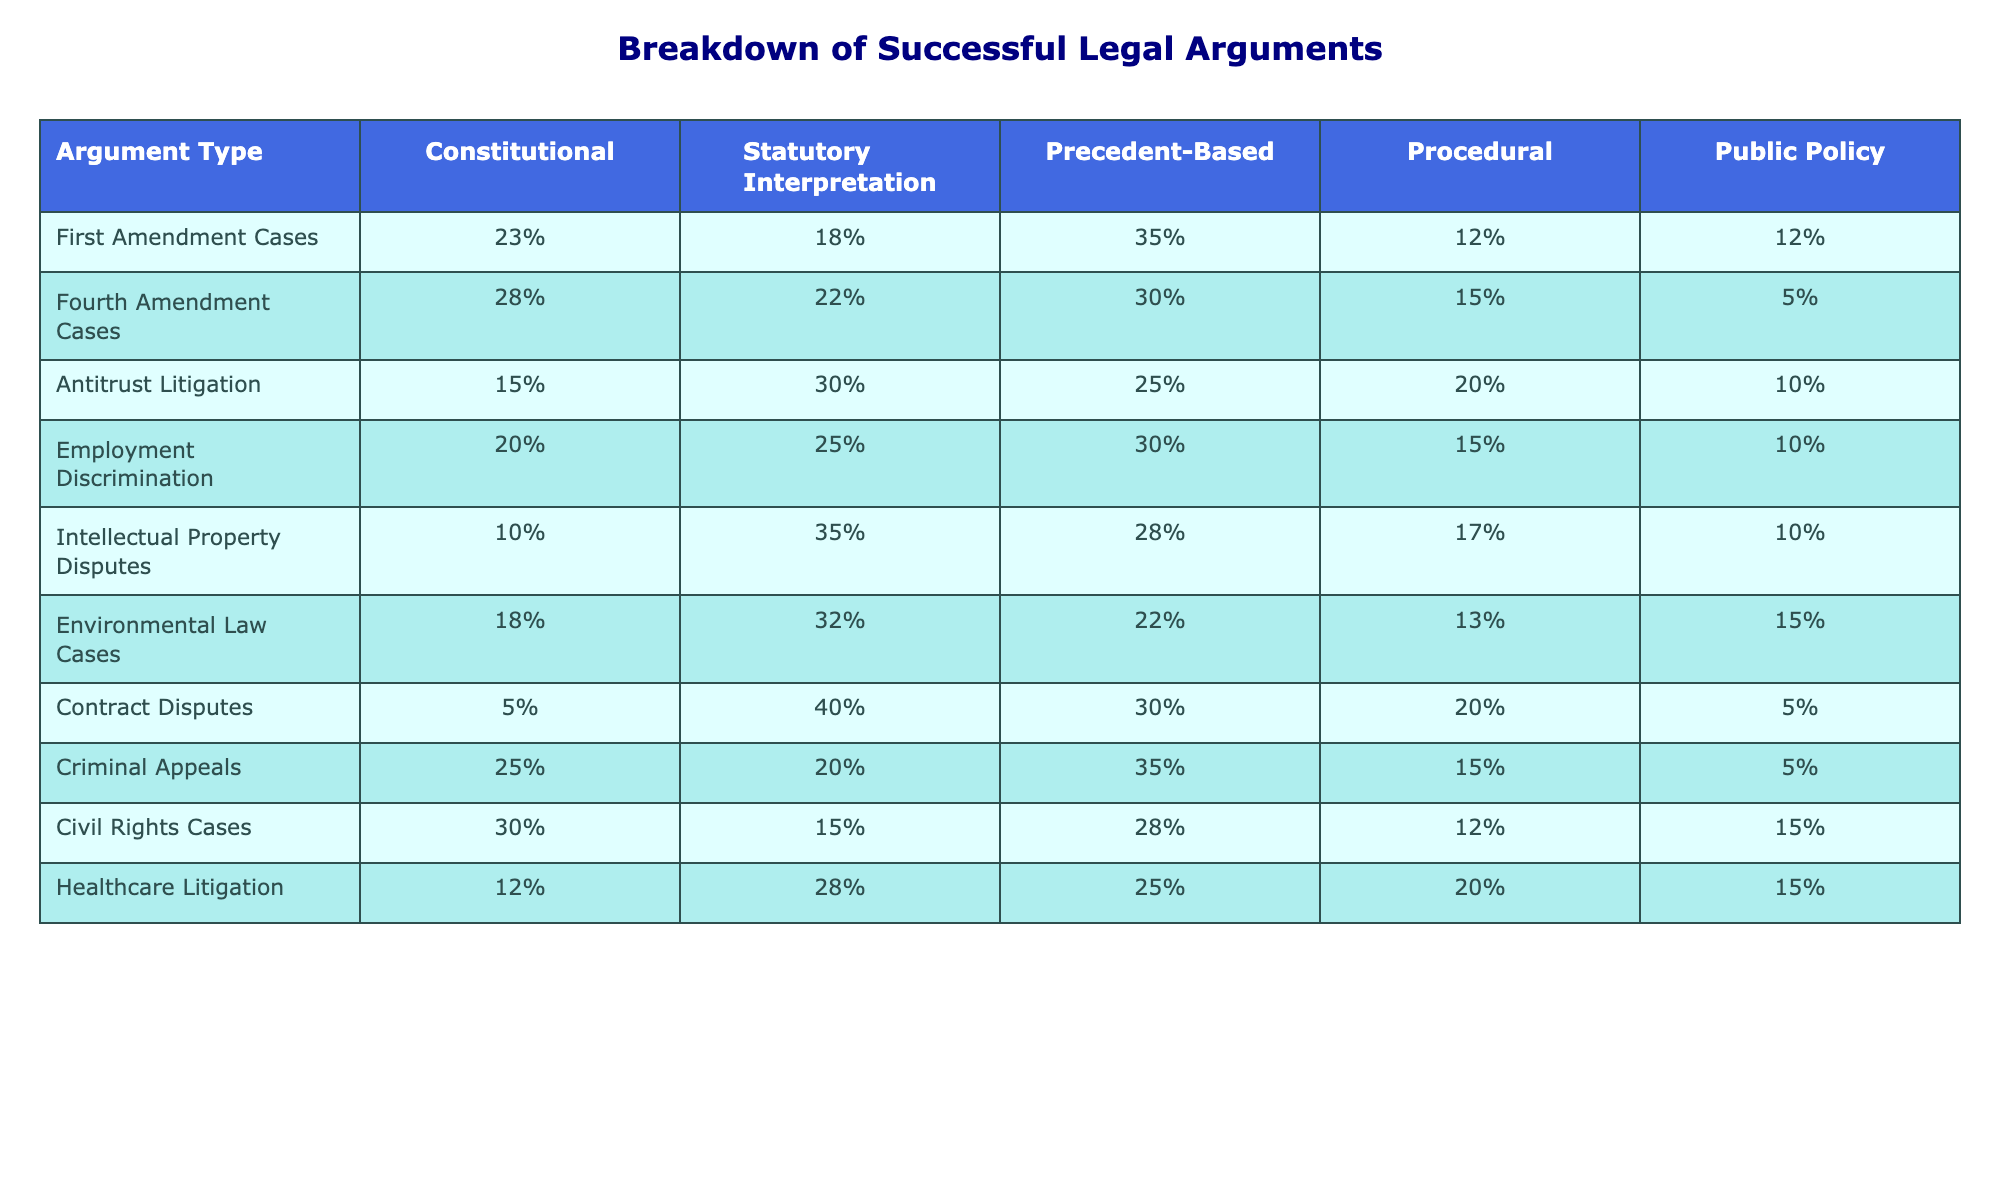What is the highest percentage of successful legal arguments in First Amendment cases for Procedural? According to the table, the highest percentage for Procedural arguments in First Amendment cases is 12%.
Answer: 12% Which type of argument is most frequently used in Fourth Amendment cases? In Fourth Amendment cases, the most frequently used argument is Constitutional, which is at 28%.
Answer: Constitutional What percentage of successful legal arguments in Antitrust Litigation are based on Public Policy? The table shows that Public Policy arguments constitute 10% of successful legal arguments in Antitrust Litigation.
Answer: 10% What argument type shows the least usage in Contract Disputes? The least used argument type in Contract Disputes is Constitutional, with only 5% usage.
Answer: Constitutional In Employment Discrimination cases, what is the difference between the percentages of Statutory Interpretation and Public Policy arguments? Statutory Interpretation arguments are 25%, while Public Policy arguments are 10%. The difference is 25 - 10 = 15%.
Answer: 15% What is the average percentage of Procedural arguments across all case types? Adding the percentages for Procedural argument (12 + 15 + 20 + 15 + 17 + 13 + 20 + 15 + 12 + 20) gives a total of  165%. Dividing by 10 (the number of cases) results in 16.5%.
Answer: 16.5% Are there any case types where Public Policy arguments make up less than 10% of successful arguments? Yes, in Fourth Amendment cases, it is only 5%.
Answer: Yes Which argument type is most used in Intellectual Property Disputes? In Intellectual Property Disputes, Statutory Interpretation is the most used argument type, at 35%.
Answer: Statutory Interpretation If we compare Criminal Appeals and Civil Rights Cases, which argument type is most prominent in terms of percentage in Criminal Appeals? In Criminal Appeals, the most prominent argument type is Precedent-Based at 35%.
Answer: Precedent-Based What is the total percentage accounted for by all argument types in Environmental Law Cases? The total percentage is obtained by adding all argument types (18 + 32 + 22 + 13 + 15) which equals 100%.
Answer: 100% 